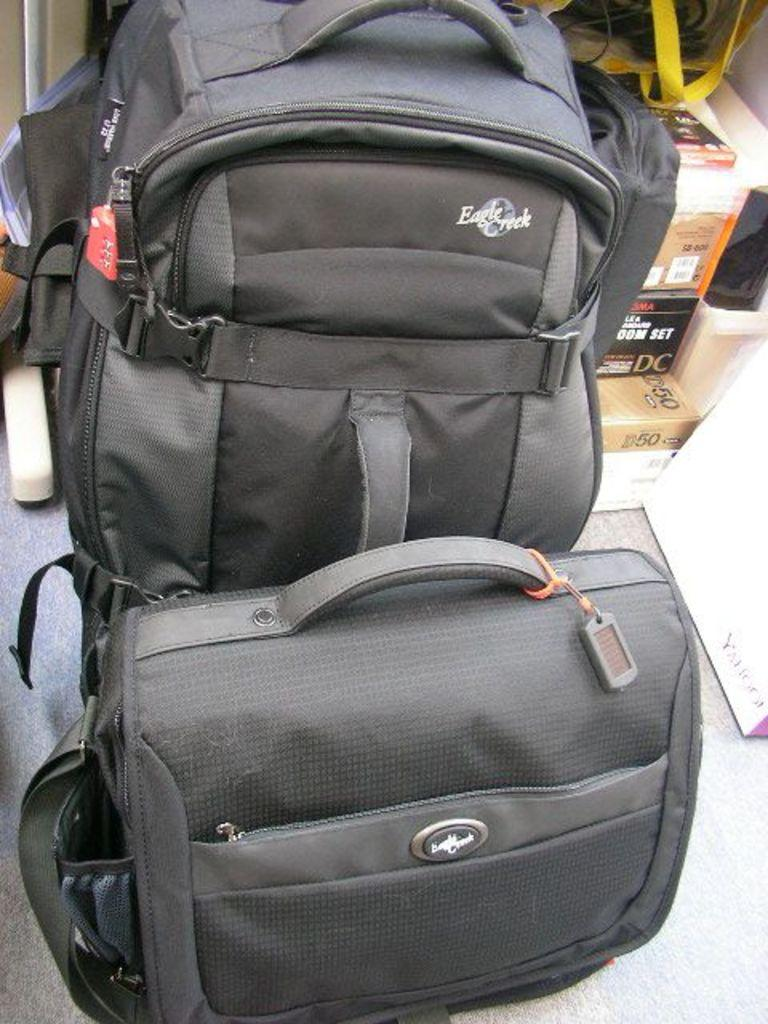What objects are on the floor in the image? There are bags on the floor in the image. What can be seen on the right side of the image? There are carton boxes on the right side of the image. Where was the image taken? The image was taken inside a house. What theory is being discussed by the expert in the image? There is no expert or discussion present in the image; it only shows bags on the floor and carton boxes on the right side. 